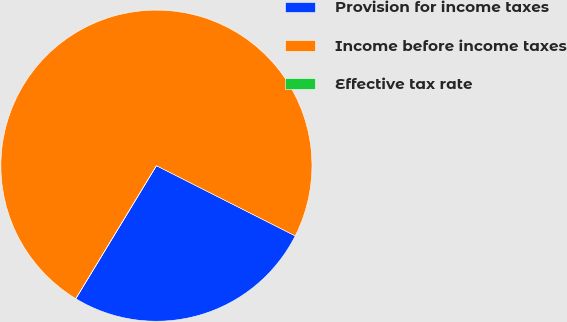Convert chart. <chart><loc_0><loc_0><loc_500><loc_500><pie_chart><fcel>Provision for income taxes<fcel>Income before income taxes<fcel>Effective tax rate<nl><fcel>26.22%<fcel>73.78%<fcel>0.0%<nl></chart> 